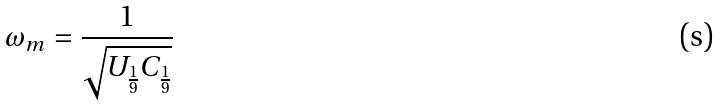Convert formula to latex. <formula><loc_0><loc_0><loc_500><loc_500>\omega _ { m } = \frac { 1 } { \sqrt { U _ { \frac { 1 } { 9 } } C _ { \frac { 1 } { 9 } } } }</formula> 